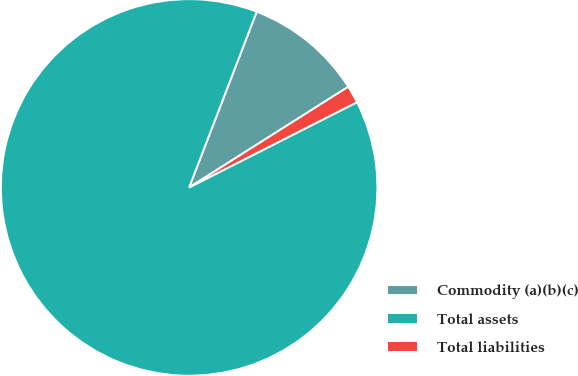Convert chart. <chart><loc_0><loc_0><loc_500><loc_500><pie_chart><fcel>Commodity (a)(b)(c)<fcel>Total assets<fcel>Total liabilities<nl><fcel>10.18%<fcel>88.32%<fcel>1.5%<nl></chart> 